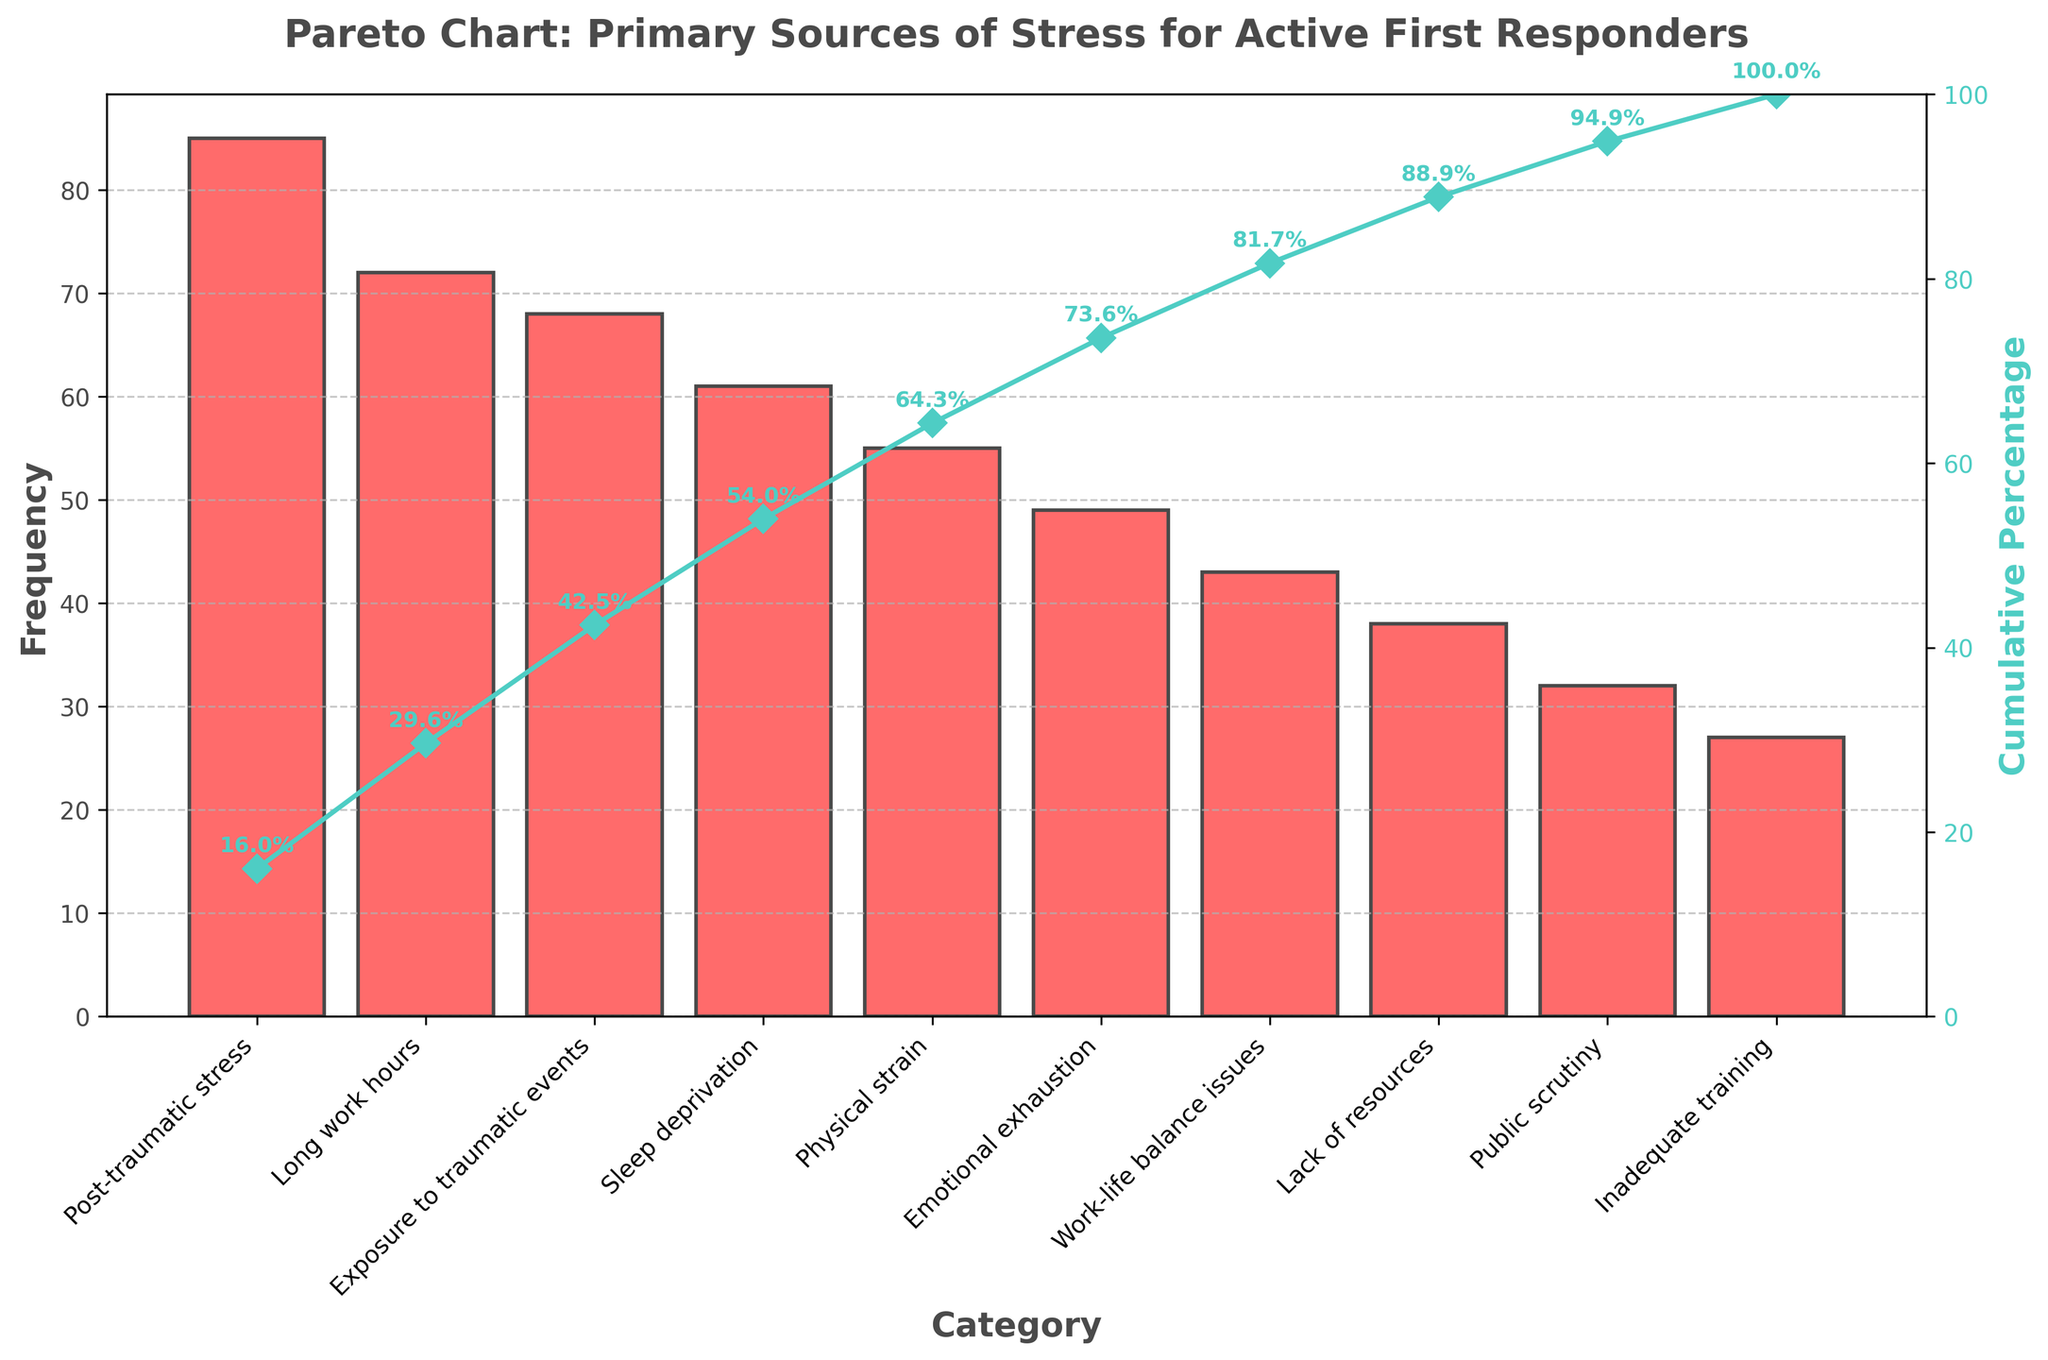What is the title of the chart? The title of the chart is usually found at the top of the figure, describing the content of the chart. In this case, it states "Pareto Chart: Primary Sources of Stress for Active First Responders."
Answer: Pareto Chart: Primary Sources of Stress for Active First Responders How many stress categories are listed in the chart? By counting the distinct bars in the bar plot, you can see how many different categories are presented. There are ten bars, meaning there are ten stress categories.
Answer: 10 What category has the highest frequency? Look at the highest bar in the chart. The tallest bar represents the category "Post-traumatic stress."
Answer: Post-traumatic stress Which category is more frequent: "Sleep deprivation" or "Public scrutiny"? Compare the heights of the bars corresponding to "Sleep deprivation" and "Public scrutiny." “Sleep deprivation” has a higher bar than “Public scrutiny.”
Answer: Sleep deprivation What is the approximate cumulative percentage for "Sleep deprivation"? Follow the line plot to the point above "Sleep deprivation" and read the cumulative percentage from the right y-axis. It is approximately 70%.
Answer: 70% How does the cumulative percentage change between "Physical strain" and "Work-life balance issues"? Locate "Physical strain" and "Work-life balance issues" and note their cumulative percentages. The percentage increases from around 79% for "Physical strain" to approximately 89% for "Work-life balance issues." The difference is about 10%.
Answer: 10% Which categories contribute to the cumulative percentage reaching approximately 90%? Identify the point where the cumulative line reaches 90% and note the categories up to that point. The categories are "Post-traumatic stress," "Long work hours," "Exposure to traumatic events," "Sleep deprivation," "Physical strain," "Emotional exhaustion," and "Work-life balance issues."
Answer: Post-traumatic stress, Long work hours, Exposure to traumatic events, Sleep deprivation, Physical strain, Emotional exhaustion, Work-life balance issues What is the cumulative percentage after the first three most frequent stress categories? Add the frequencies of "Post-traumatic stress," "Long work hours," and "Exposure to traumatic events" and calculate the cumulative percentage. The cumulative percentage after these three categories is around 65%.
Answer: 65% Compare the frequency of "Emotional exhaustion" to "Lack of resources." Which one is higher and by how much? Compare the heights of the bars for "Emotional exhaustion" and "Lack of resources." "Emotional exhaustion" has a frequency of 49, while "Lack of resources" has a frequency of 38. The difference is 49 - 38 = 11.
Answer: Emotional exhaustion is higher by 11 